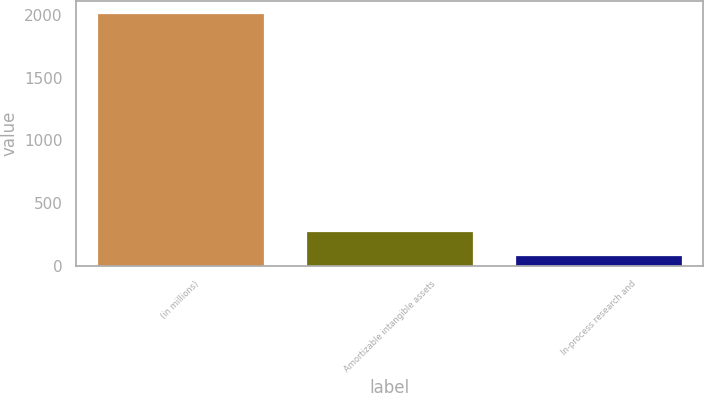<chart> <loc_0><loc_0><loc_500><loc_500><bar_chart><fcel>(in millions)<fcel>Amortizable intangible assets<fcel>In-process research and<nl><fcel>2014<fcel>280.6<fcel>88<nl></chart> 